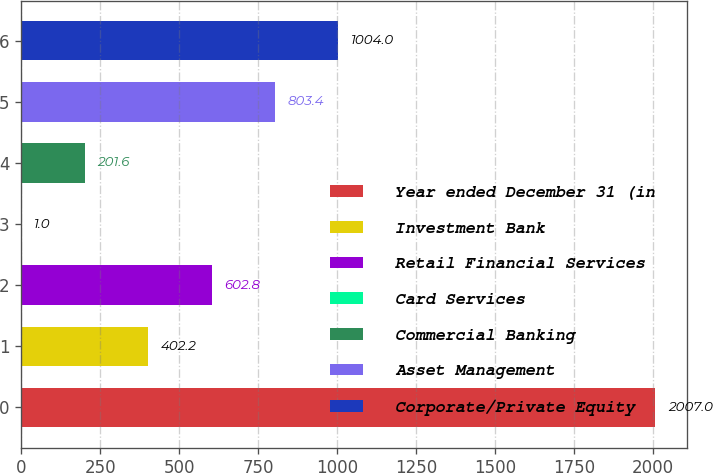Convert chart. <chart><loc_0><loc_0><loc_500><loc_500><bar_chart><fcel>Year ended December 31 (in<fcel>Investment Bank<fcel>Retail Financial Services<fcel>Card Services<fcel>Commercial Banking<fcel>Asset Management<fcel>Corporate/Private Equity<nl><fcel>2007<fcel>402.2<fcel>602.8<fcel>1<fcel>201.6<fcel>803.4<fcel>1004<nl></chart> 